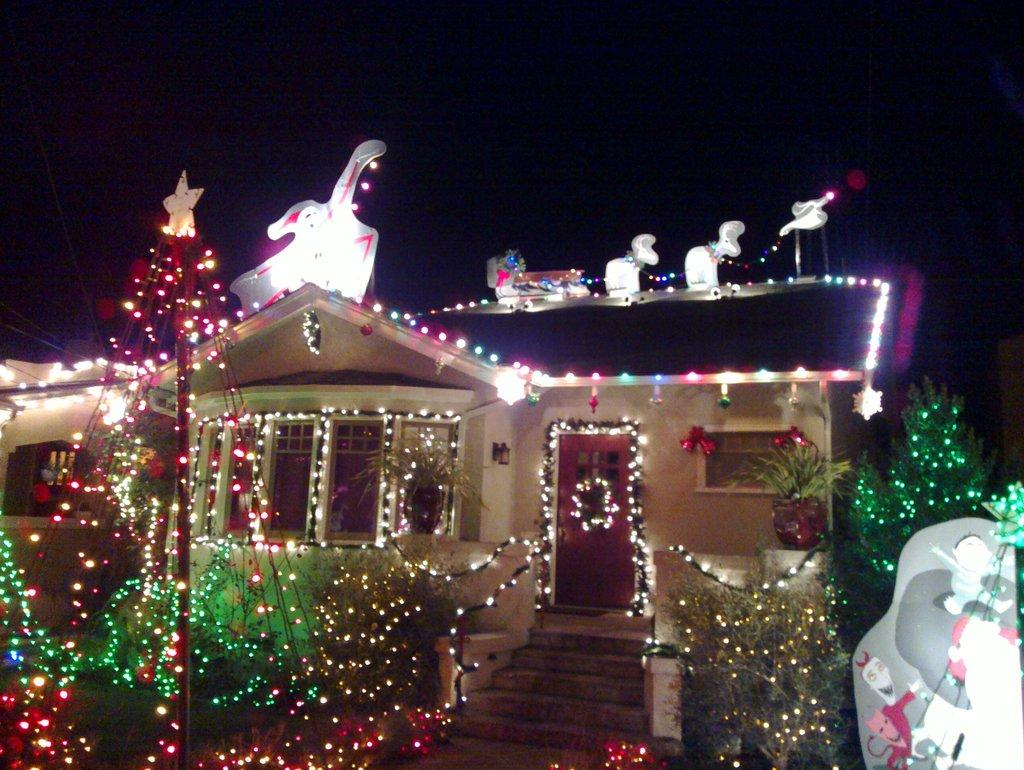What type of structure is visible in the image? There is a home in the image. What features can be seen on the home? The home has windows and doors. How is the home decorated in the image? The home is decorated with colorful lights. When was the image taken? The image was taken at night time. What type of sack can be seen hanging from the door of the home in the image? There is no sack hanging from the door of the home in the image. What is the weather like in the image? The provided facts do not mention the weather, so we cannot determine the weather from the image. 